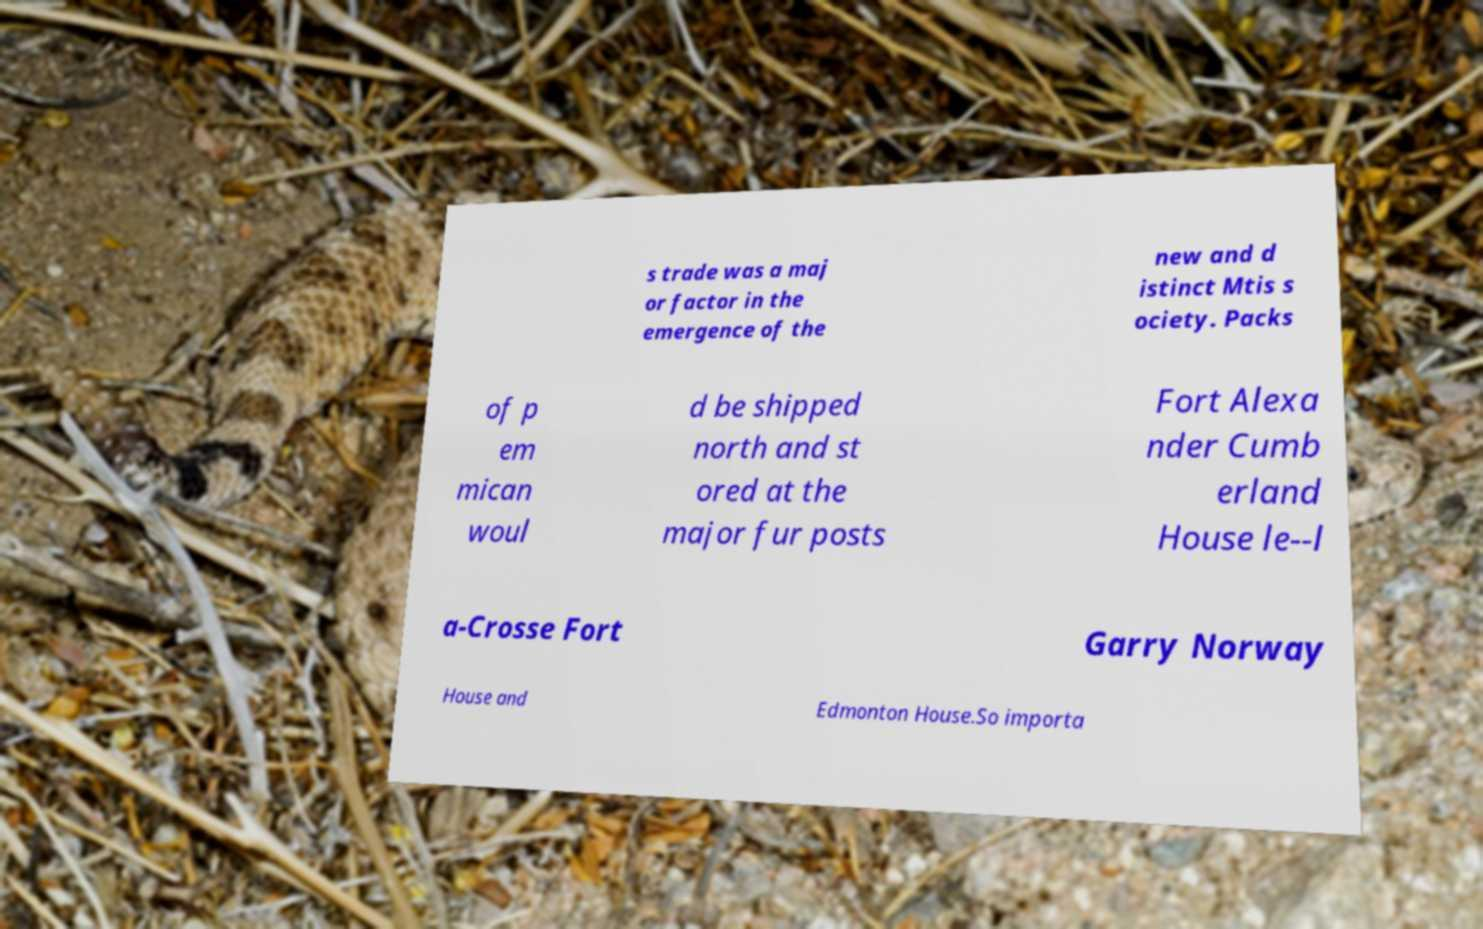There's text embedded in this image that I need extracted. Can you transcribe it verbatim? s trade was a maj or factor in the emergence of the new and d istinct Mtis s ociety. Packs of p em mican woul d be shipped north and st ored at the major fur posts Fort Alexa nder Cumb erland House le--l a-Crosse Fort Garry Norway House and Edmonton House.So importa 